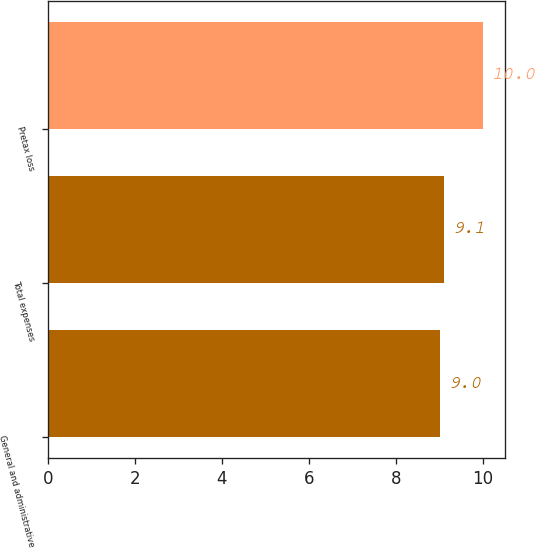Convert chart. <chart><loc_0><loc_0><loc_500><loc_500><bar_chart><fcel>General and administrative<fcel>Total expenses<fcel>Pretax loss<nl><fcel>9<fcel>9.1<fcel>10<nl></chart> 